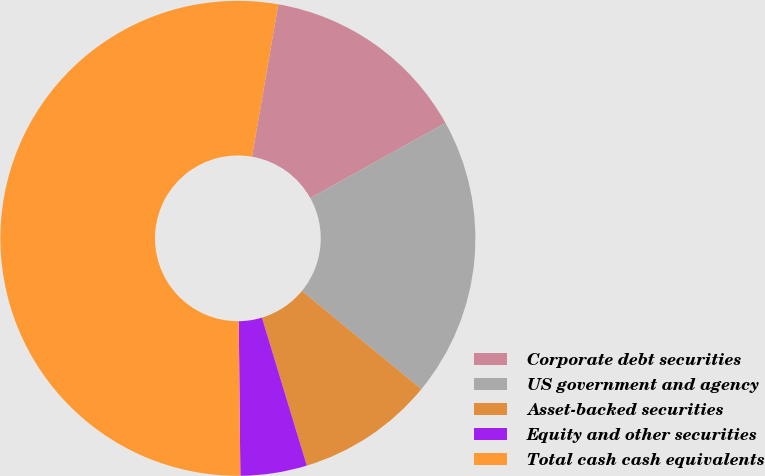<chart> <loc_0><loc_0><loc_500><loc_500><pie_chart><fcel>Corporate debt securities<fcel>US government and agency<fcel>Asset-backed securities<fcel>Equity and other securities<fcel>Total cash cash equivalents<nl><fcel>14.2%<fcel>19.03%<fcel>9.36%<fcel>4.52%<fcel>52.89%<nl></chart> 